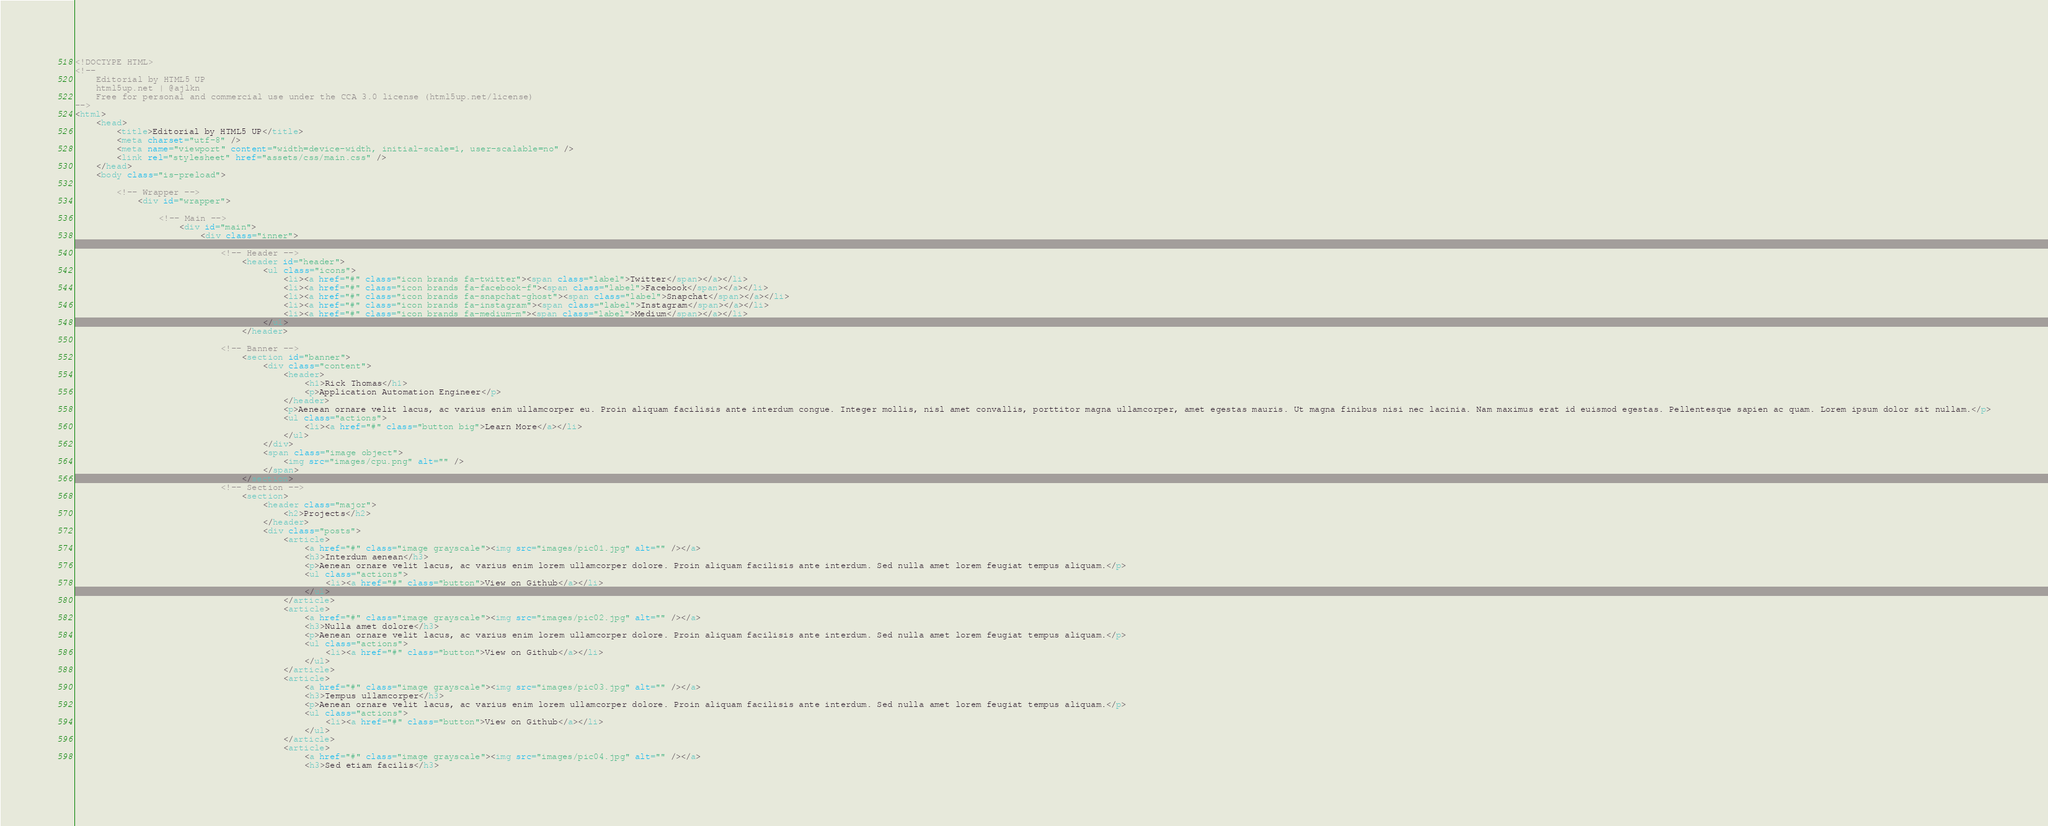Convert code to text. <code><loc_0><loc_0><loc_500><loc_500><_HTML_><!DOCTYPE HTML>
<!--
	Editorial by HTML5 UP
	html5up.net | @ajlkn
	Free for personal and commercial use under the CCA 3.0 license (html5up.net/license)
-->
<html>
	<head>
		<title>Editorial by HTML5 UP</title>
		<meta charset="utf-8" />
		<meta name="viewport" content="width=device-width, initial-scale=1, user-scalable=no" />
		<link rel="stylesheet" href="assets/css/main.css" />
	</head>
	<body class="is-preload">

		<!-- Wrapper -->
			<div id="wrapper">

				<!-- Main -->
					<div id="main">
						<div class="inner">

							<!-- Header -->
								<header id="header">
									<ul class="icons">
										<li><a href="#" class="icon brands fa-twitter"><span class="label">Twitter</span></a></li>
										<li><a href="#" class="icon brands fa-facebook-f"><span class="label">Facebook</span></a></li>
										<li><a href="#" class="icon brands fa-snapchat-ghost"><span class="label">Snapchat</span></a></li>
										<li><a href="#" class="icon brands fa-instagram"><span class="label">Instagram</span></a></li>
										<li><a href="#" class="icon brands fa-medium-m"><span class="label">Medium</span></a></li>
									</ul>
								</header>

							<!-- Banner -->
								<section id="banner">
									<div class="content">
										<header>
											<h1>Rick Thomas</h1>
											<p>Application Automation Engineer</p>
										</header>
										<p>Aenean ornare velit lacus, ac varius enim ullamcorper eu. Proin aliquam facilisis ante interdum congue. Integer mollis, nisl amet convallis, porttitor magna ullamcorper, amet egestas mauris. Ut magna finibus nisi nec lacinia. Nam maximus erat id euismod egestas. Pellentesque sapien ac quam. Lorem ipsum dolor sit nullam.</p>
										<ul class="actions">
											<li><a href="#" class="button big">Learn More</a></li>
										</ul>
									</div>
									<span class="image object">
										<img src="images/cpu.png" alt="" />
									</span>
								</section>
							<!-- Section -->
								<section>
									<header class="major">
										<h2>Projects</h2>
									</header>
									<div class="posts">
										<article>
											<a href="#" class="image grayscale"><img src="images/pic01.jpg" alt="" /></a>
											<h3>Interdum aenean</h3>
											<p>Aenean ornare velit lacus, ac varius enim lorem ullamcorper dolore. Proin aliquam facilisis ante interdum. Sed nulla amet lorem feugiat tempus aliquam.</p>
											<ul class="actions">
												<li><a href="#" class="button">View on Github</a></li>
											</ul>
										</article>
										<article>
											<a href="#" class="image grayscale"><img src="images/pic02.jpg" alt="" /></a>
											<h3>Nulla amet dolore</h3>
											<p>Aenean ornare velit lacus, ac varius enim lorem ullamcorper dolore. Proin aliquam facilisis ante interdum. Sed nulla amet lorem feugiat tempus aliquam.</p>
											<ul class="actions">
												<li><a href="#" class="button">View on Github</a></li>
											</ul>
										</article>
										<article>
											<a href="#" class="image grayscale"><img src="images/pic03.jpg" alt="" /></a>
											<h3>Tempus ullamcorper</h3>
											<p>Aenean ornare velit lacus, ac varius enim lorem ullamcorper dolore. Proin aliquam facilisis ante interdum. Sed nulla amet lorem feugiat tempus aliquam.</p>
											<ul class="actions">
												<li><a href="#" class="button">View on Github</a></li>
											</ul>
										</article>
										<article>
											<a href="#" class="image grayscale"><img src="images/pic04.jpg" alt="" /></a>
											<h3>Sed etiam facilis</h3></code> 